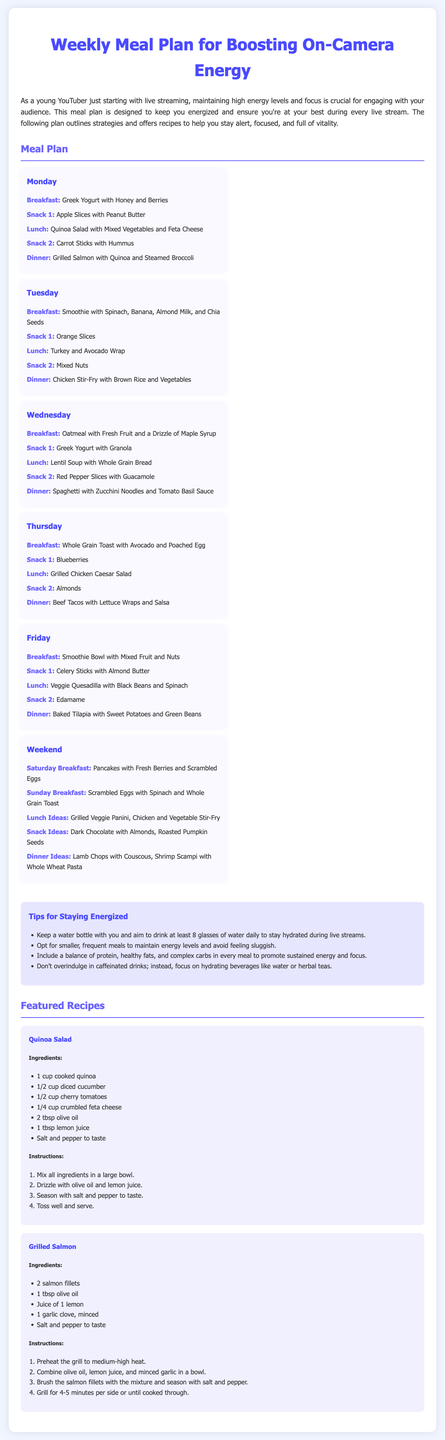What is the first day's breakfast? The first day's breakfast listed in the meal plan is Greek Yogurt with Honey and Berries.
Answer: Greek Yogurt with Honey and Berries How many snacks are included on Tuesday? Tuesday includes a total of two snacks, Snack 1 and Snack 2.
Answer: 2 What is the main protein source for Wednesday's dinner? Wednesday's dinner features spaghetti, but the primary protein source is not explicitly stated. However, it can be inferred that the sauce might be the main source of protein.
Answer: Tomato Basil Sauce What is one way to stay hydrated during live streams? A tip mentioned suggests keeping a water bottle and aiming to drink at least 8 glasses of water daily.
Answer: Drink at least 8 glasses of water What type of meal is Quinoa Salad? Quinoa Salad is categorized as part of lunch in the meal plan.
Answer: Lunch How many recipes are featured in the document? The document showcases two specific recipes: Quinoa Salad and Grilled Salmon.
Answer: 2 What is a suggested snack on Friday? The meal plan lists Edamame as a suggested snack on Friday.
Answer: Edamame What important ingredient is common in most dinners throughout the week? Many dinners include a form of protein, ranging from salmon to chicken to tilapia.
Answer: Protein What is the primary vegetable recommended for the breakfast on Thursday? The breakfast on Thursday features Whole Grain Toast with Avocado, where avocado is the main vegetable.
Answer: Avocado 